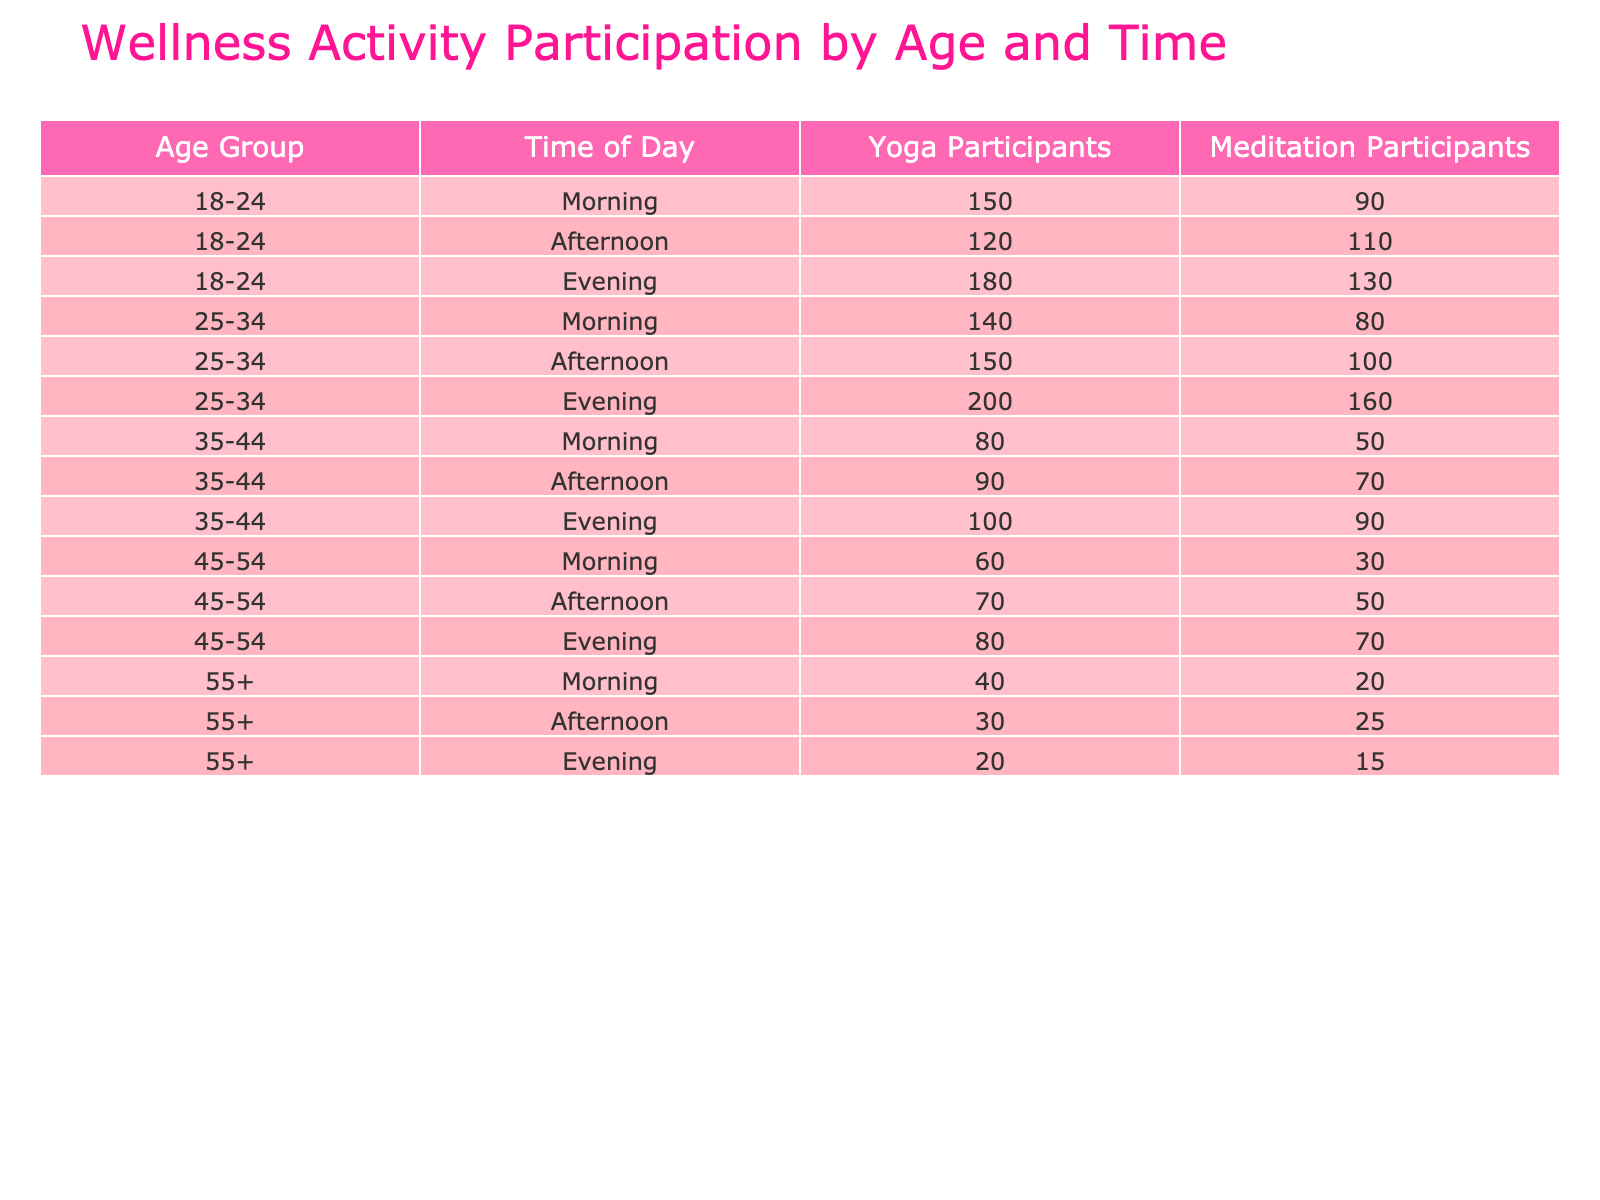What age group has the highest number of yoga participants in the evening? The evening data for each age group shows the following yoga participants: 18-24 has 180, 25-34 has 200, 35-44 has 100, 45-54 has 80, and 55+ has 20. The highest value is from the 25-34 age group with 200 participants.
Answer: 25-34 Is the number of meditation participants in the morning for the 45-54 age group greater than the number of yoga participants in the afternoon for the same age group? In the morning, the 45-54 age group has 30 meditation participants, while in the afternoon, they have 70 yoga participants. Since 30 is less than 70, the statement is false.
Answer: No What is the total number of yoga participants across all age groups in the afternoon? The number of yoga participants in the afternoon for each age group is: 18-24 has 120, 25-34 has 150, 35-44 has 90, 45-54 has 70, and 55+ has 30. Summing these gives: 120 + 150 + 90 + 70 + 30 = 460.
Answer: 460 Do more yoga participants attend morning sessions compared to evening sessions for the 35-44 age group? For the 35-44 age group, there are 80 yoga participants in the morning and 100 in the evening. Since 80 is less than 100, more participants attend the evening session.
Answer: No What is the average number of meditation participants for the age group 18-24? The number of meditation participants for the 18-24 age group is: morning 90, afternoon 110, evening 130. The sum is: 90 + 110 + 130 = 330. Dividing by the number of time slots (3) gives an average of 330 / 3 = 110.
Answer: 110 How does the total number of meditation participants during the morning compare to the total in the evening across all age groups? In the morning, the total number of meditation participants is: 90 (18-24) + 80 (25-34) + 50 (35-44) + 30 (45-54) + 20 (55+) = 270. In the evening, the total is: 130 (18-24) + 160 (25-34) + 90 (35-44) + 70 (45-54) + 15 (55+) = 465. Since 270 is less than 465, the morning total is lower.
Answer: Morning total is lower 